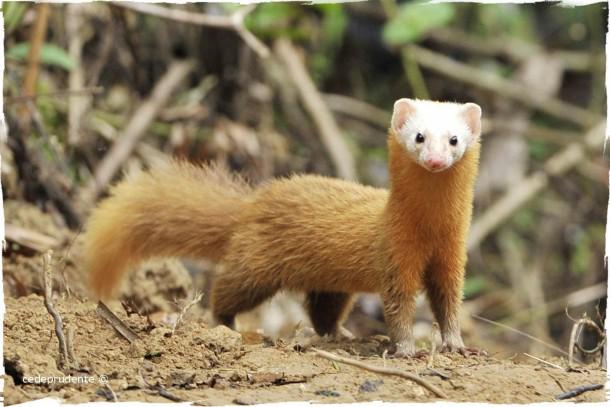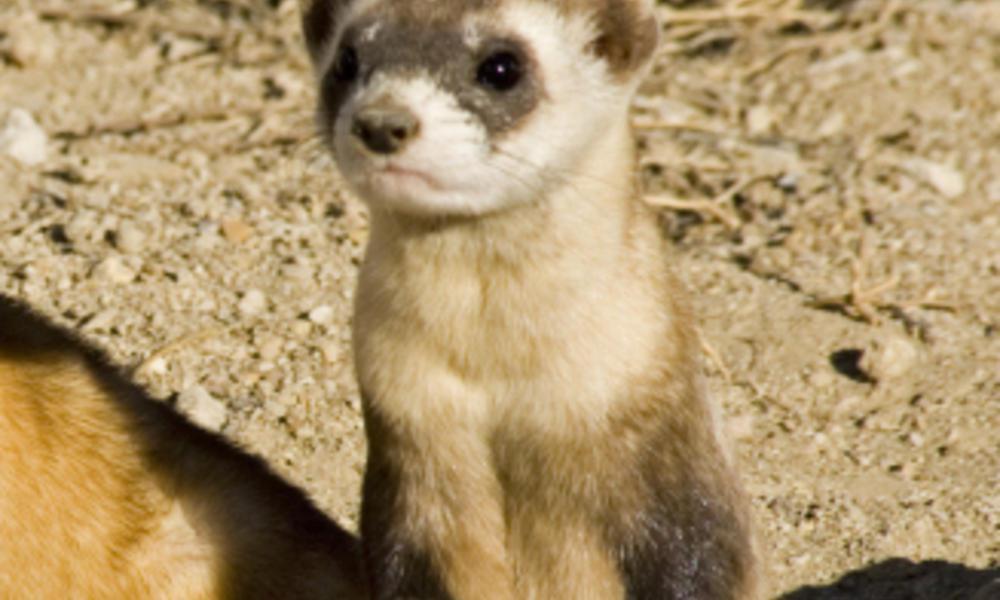The first image is the image on the left, the second image is the image on the right. Considering the images on both sides, is "At least one image has only one weasel." valid? Answer yes or no. Yes. 